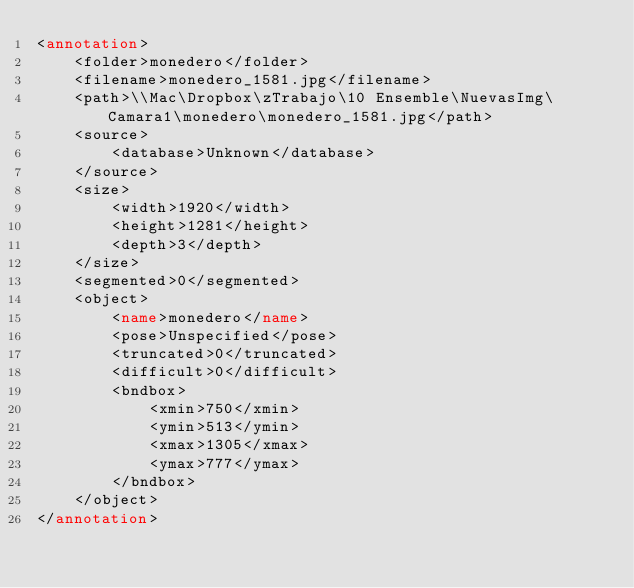<code> <loc_0><loc_0><loc_500><loc_500><_XML_><annotation>
	<folder>monedero</folder>
	<filename>monedero_1581.jpg</filename>
	<path>\\Mac\Dropbox\zTrabajo\10 Ensemble\NuevasImg\Camara1\monedero\monedero_1581.jpg</path>
	<source>
		<database>Unknown</database>
	</source>
	<size>
		<width>1920</width>
		<height>1281</height>
		<depth>3</depth>
	</size>
	<segmented>0</segmented>
	<object>
		<name>monedero</name>
		<pose>Unspecified</pose>
		<truncated>0</truncated>
		<difficult>0</difficult>
		<bndbox>
			<xmin>750</xmin>
			<ymin>513</ymin>
			<xmax>1305</xmax>
			<ymax>777</ymax>
		</bndbox>
	</object>
</annotation>
</code> 